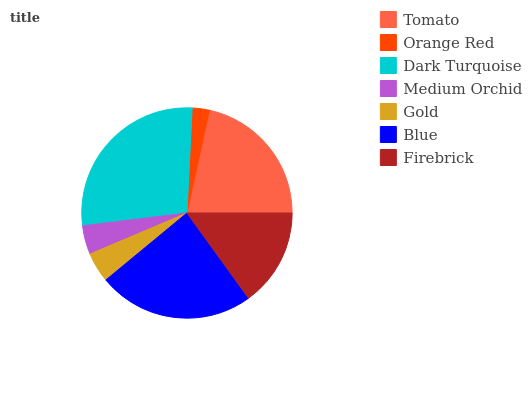Is Orange Red the minimum?
Answer yes or no. Yes. Is Dark Turquoise the maximum?
Answer yes or no. Yes. Is Dark Turquoise the minimum?
Answer yes or no. No. Is Orange Red the maximum?
Answer yes or no. No. Is Dark Turquoise greater than Orange Red?
Answer yes or no. Yes. Is Orange Red less than Dark Turquoise?
Answer yes or no. Yes. Is Orange Red greater than Dark Turquoise?
Answer yes or no. No. Is Dark Turquoise less than Orange Red?
Answer yes or no. No. Is Firebrick the high median?
Answer yes or no. Yes. Is Firebrick the low median?
Answer yes or no. Yes. Is Gold the high median?
Answer yes or no. No. Is Orange Red the low median?
Answer yes or no. No. 